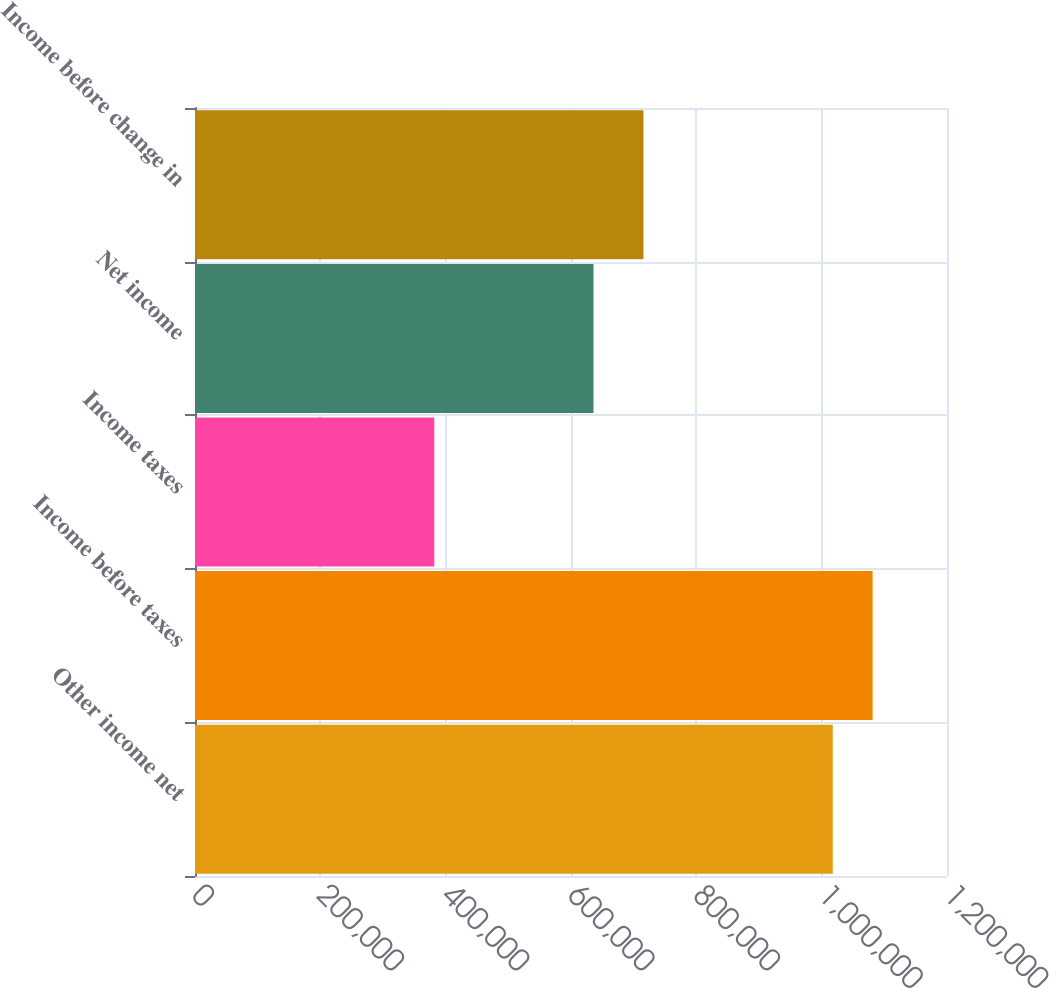Convert chart to OTSL. <chart><loc_0><loc_0><loc_500><loc_500><bar_chart><fcel>Other income net<fcel>Income before taxes<fcel>Income taxes<fcel>Net income<fcel>Income before change in<nl><fcel>1.01772e+06<fcel>1.0813e+06<fcel>381858<fcel>635857<fcel>715608<nl></chart> 